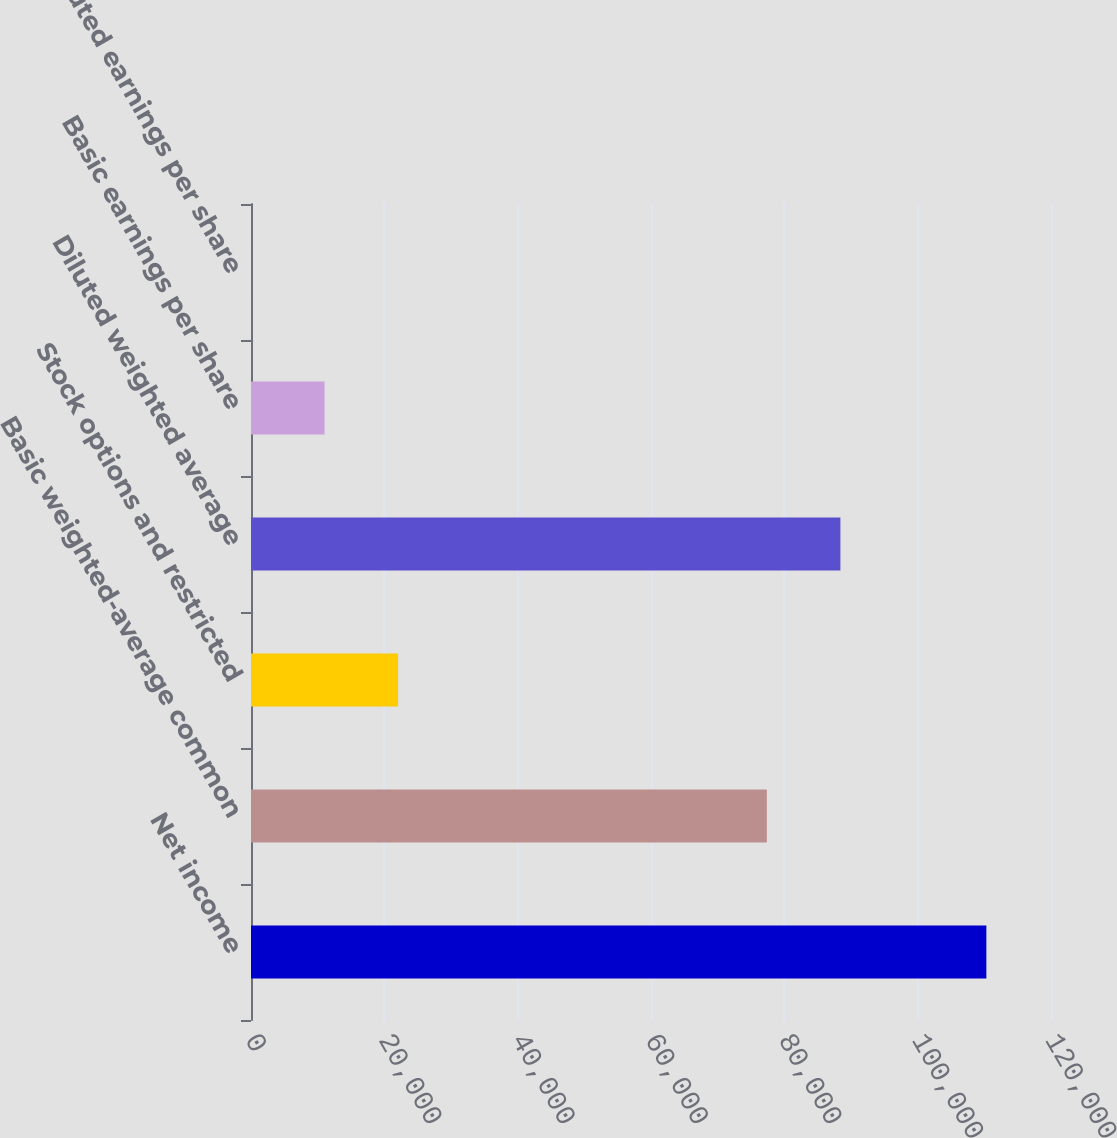Convert chart to OTSL. <chart><loc_0><loc_0><loc_500><loc_500><bar_chart><fcel>Net income<fcel>Basic weighted-average common<fcel>Stock options and restricted<fcel>Diluted weighted average<fcel>Basic earnings per share<fcel>Diluted earnings per share<nl><fcel>110303<fcel>77378<fcel>22061.7<fcel>88408.2<fcel>11031.6<fcel>1.4<nl></chart> 